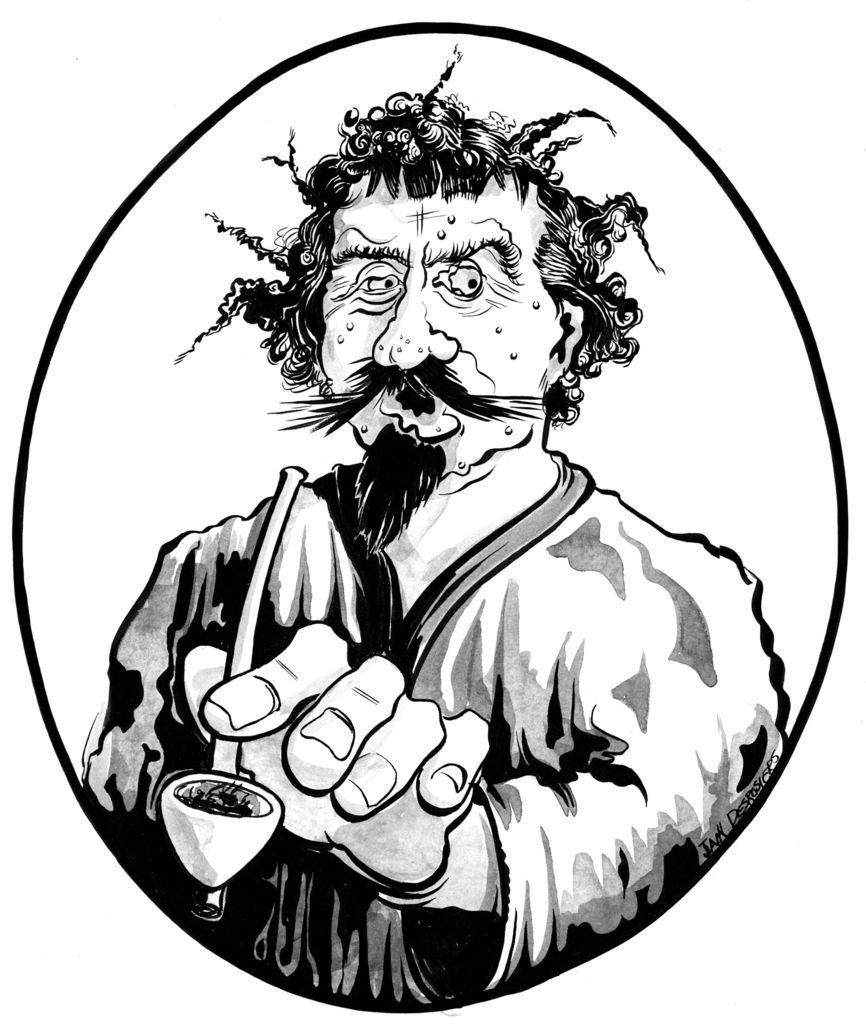What is depicted in the image? There is a sketch of a person in the image. What color is the background of the image? The background of the image is white. How many chairs are visible in the image? There are no chairs present in the image; it features a sketch of a person on a white background. What type of wind can be seen blowing in the image? There is no wind or blowing action depicted in the image; it is a static sketch of a person on a white background. 